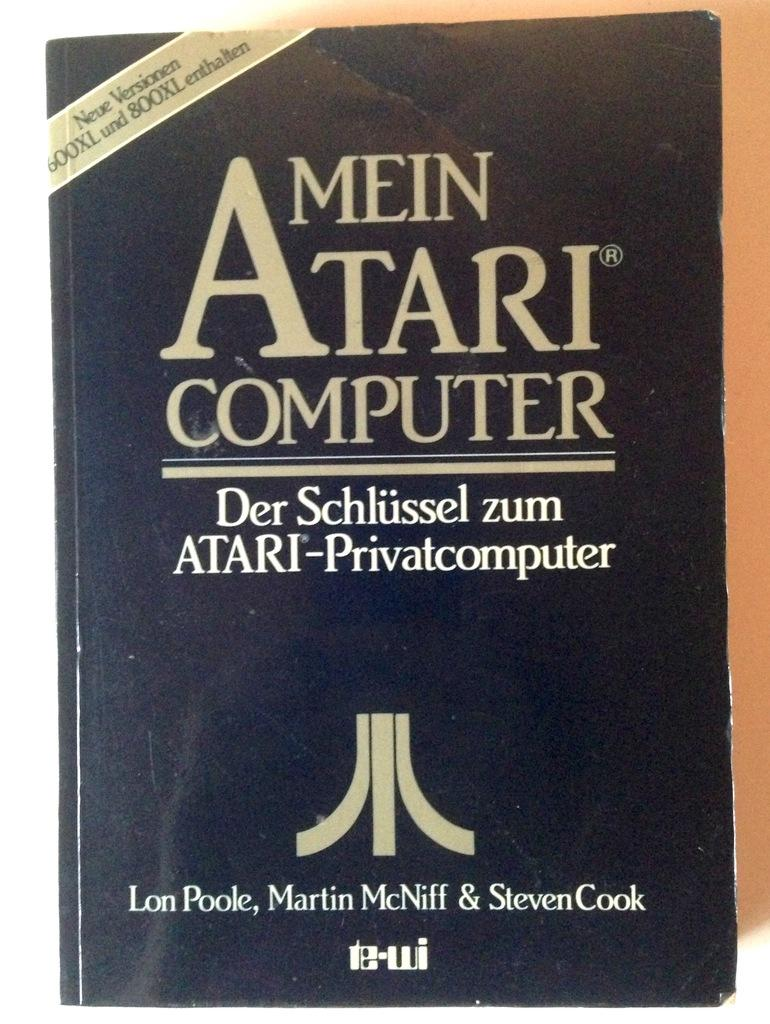Provide a one-sentence caption for the provided image. A black book is titled Mein Atari Computer. 